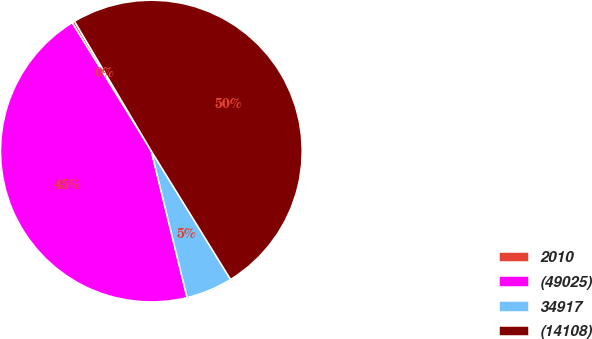<chart> <loc_0><loc_0><loc_500><loc_500><pie_chart><fcel>2010<fcel>(49025)<fcel>34917<fcel>(14108)<nl><fcel>0.29%<fcel>45.01%<fcel>4.99%<fcel>49.71%<nl></chart> 